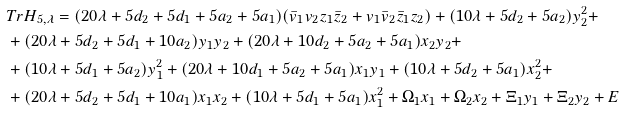<formula> <loc_0><loc_0><loc_500><loc_500>& T r H _ { 5 , \lambda } = ( 2 0 \lambda + 5 d _ { 2 } + 5 d _ { 1 } + 5 a _ { 2 } + 5 a _ { 1 } ) ( \bar { v } _ { 1 } v _ { 2 } z _ { 1 } \bar { z } _ { 2 } + v _ { 1 } \bar { v } _ { 2 } \bar { z } _ { 1 } z _ { 2 } ) + ( 1 0 \lambda + 5 d _ { 2 } + 5 a _ { 2 } ) y _ { 2 } ^ { 2 } + \\ & + ( 2 0 \lambda + 5 d _ { 2 } + 5 d _ { 1 } + 1 0 a _ { 2 } ) y _ { 1 } y _ { 2 } + ( 2 0 \lambda + 1 0 d _ { 2 } + 5 a _ { 2 } + 5 a _ { 1 } ) x _ { 2 } y _ { 2 } + \\ & + ( 1 0 \lambda + 5 d _ { 1 } + 5 a _ { 2 } ) y _ { 1 } ^ { 2 } + ( 2 0 \lambda + 1 0 d _ { 1 } + 5 a _ { 2 } + 5 a _ { 1 } ) x _ { 1 } y _ { 1 } + ( 1 0 \lambda + 5 d _ { 2 } + 5 a _ { 1 } ) x _ { 2 } ^ { 2 } + \\ & + ( 2 0 \lambda + 5 d _ { 2 } + 5 d _ { 1 } + 1 0 a _ { 1 } ) x _ { 1 } x _ { 2 } + ( 1 0 \lambda + 5 d _ { 1 } + 5 a _ { 1 } ) x _ { 1 } ^ { 2 } + \Omega _ { 1 } x _ { 1 } + \Omega _ { 2 } x _ { 2 } + \Xi _ { 1 } y _ { 1 } + \Xi _ { 2 } y _ { 2 } + E</formula> 